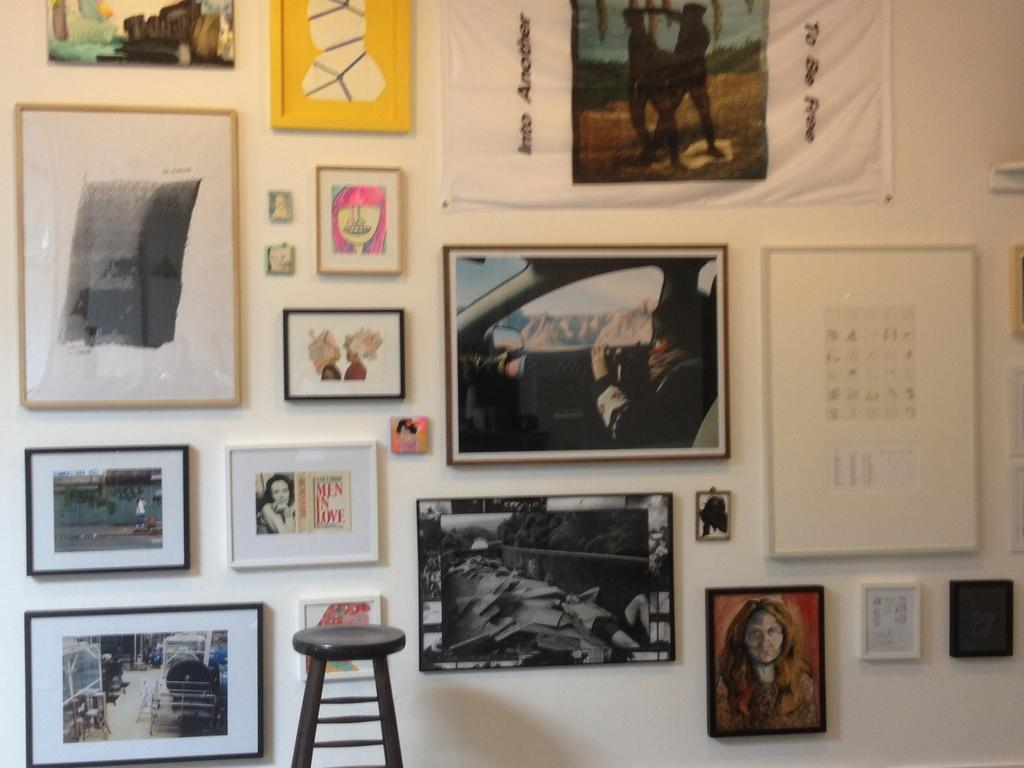What can be seen hanging on the wall in the image? There are photo frames on the wall. What type of furniture is present in the image? There is a stool in the image. Who is present in the image? There is a woman in the image. What mode of transportation is visible in the image? There is a car in the image. How many people are standing in the image? Two persons are standing in the image. Where is the steam coming from in the image? There is no steam present in the image. What type of basket is being used by the woman in the image? There is no basket present in the image. 